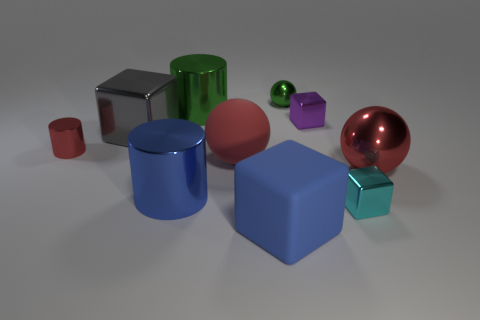Subtract all small metal balls. How many balls are left? 2 Subtract all gray blocks. How many blocks are left? 3 Subtract all gray cylinders. How many yellow blocks are left? 0 Subtract 1 gray blocks. How many objects are left? 9 Subtract all cubes. How many objects are left? 6 Subtract 2 spheres. How many spheres are left? 1 Subtract all blue cylinders. Subtract all yellow balls. How many cylinders are left? 2 Subtract all big cylinders. Subtract all purple metal things. How many objects are left? 7 Add 4 green shiny cylinders. How many green shiny cylinders are left? 5 Add 7 green metallic objects. How many green metallic objects exist? 9 